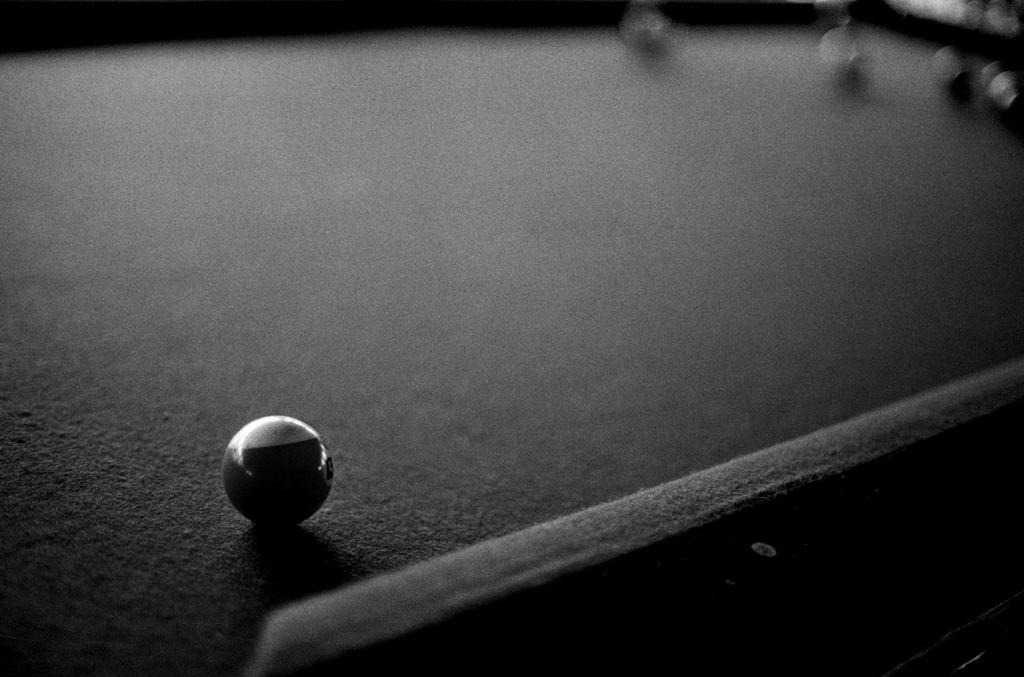What type of table is depicted in the image? The image appears to be a snooker table. Can you describe the position of the ball on the table? There is a ball on the left side of the table. What part of the image is not clear? The top part of the image is blurred. What type of letter is being written on the snooker table in the image? There is no letter being written on the snooker table in the image; it is a game table for playing snooker. Can you describe the bun that is sitting on the snooker table in the image? There is no bun present on the snooker table in the image. 